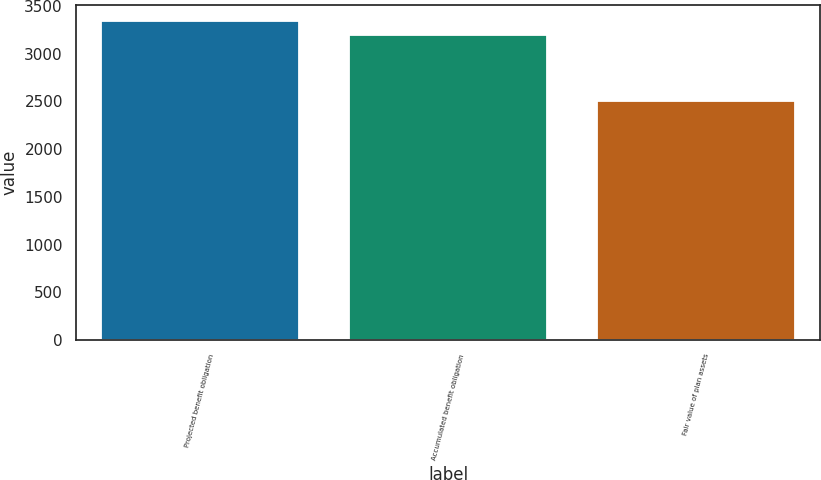Convert chart. <chart><loc_0><loc_0><loc_500><loc_500><bar_chart><fcel>Projected benefit obligation<fcel>Accumulated benefit obligation<fcel>Fair value of plan assets<nl><fcel>3342<fcel>3190<fcel>2505<nl></chart> 